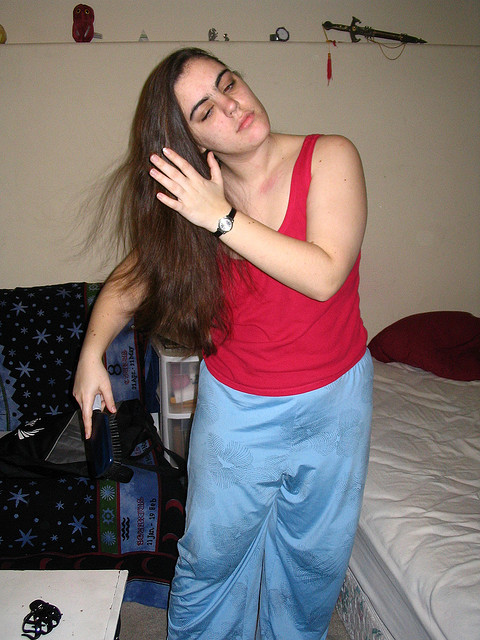<image>Is this lady getting ready to go clubbing? I am not sure if this lady is getting ready to go clubbing. Is this lady getting ready to go clubbing? I don't know if this lady is getting ready to go clubbing. It can go both ways. 